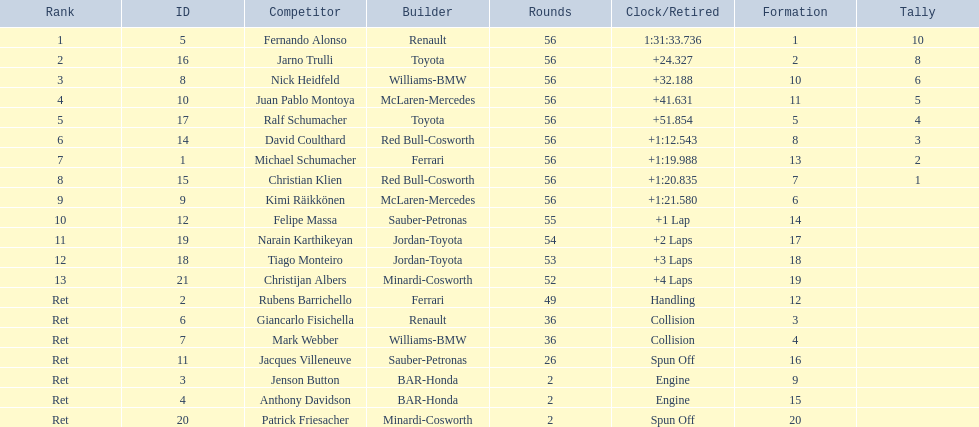Who was fernando alonso's instructor? Renault. How many laps did fernando alonso run? 56. How long did it take alonso to complete the race? 1:31:33.736. 